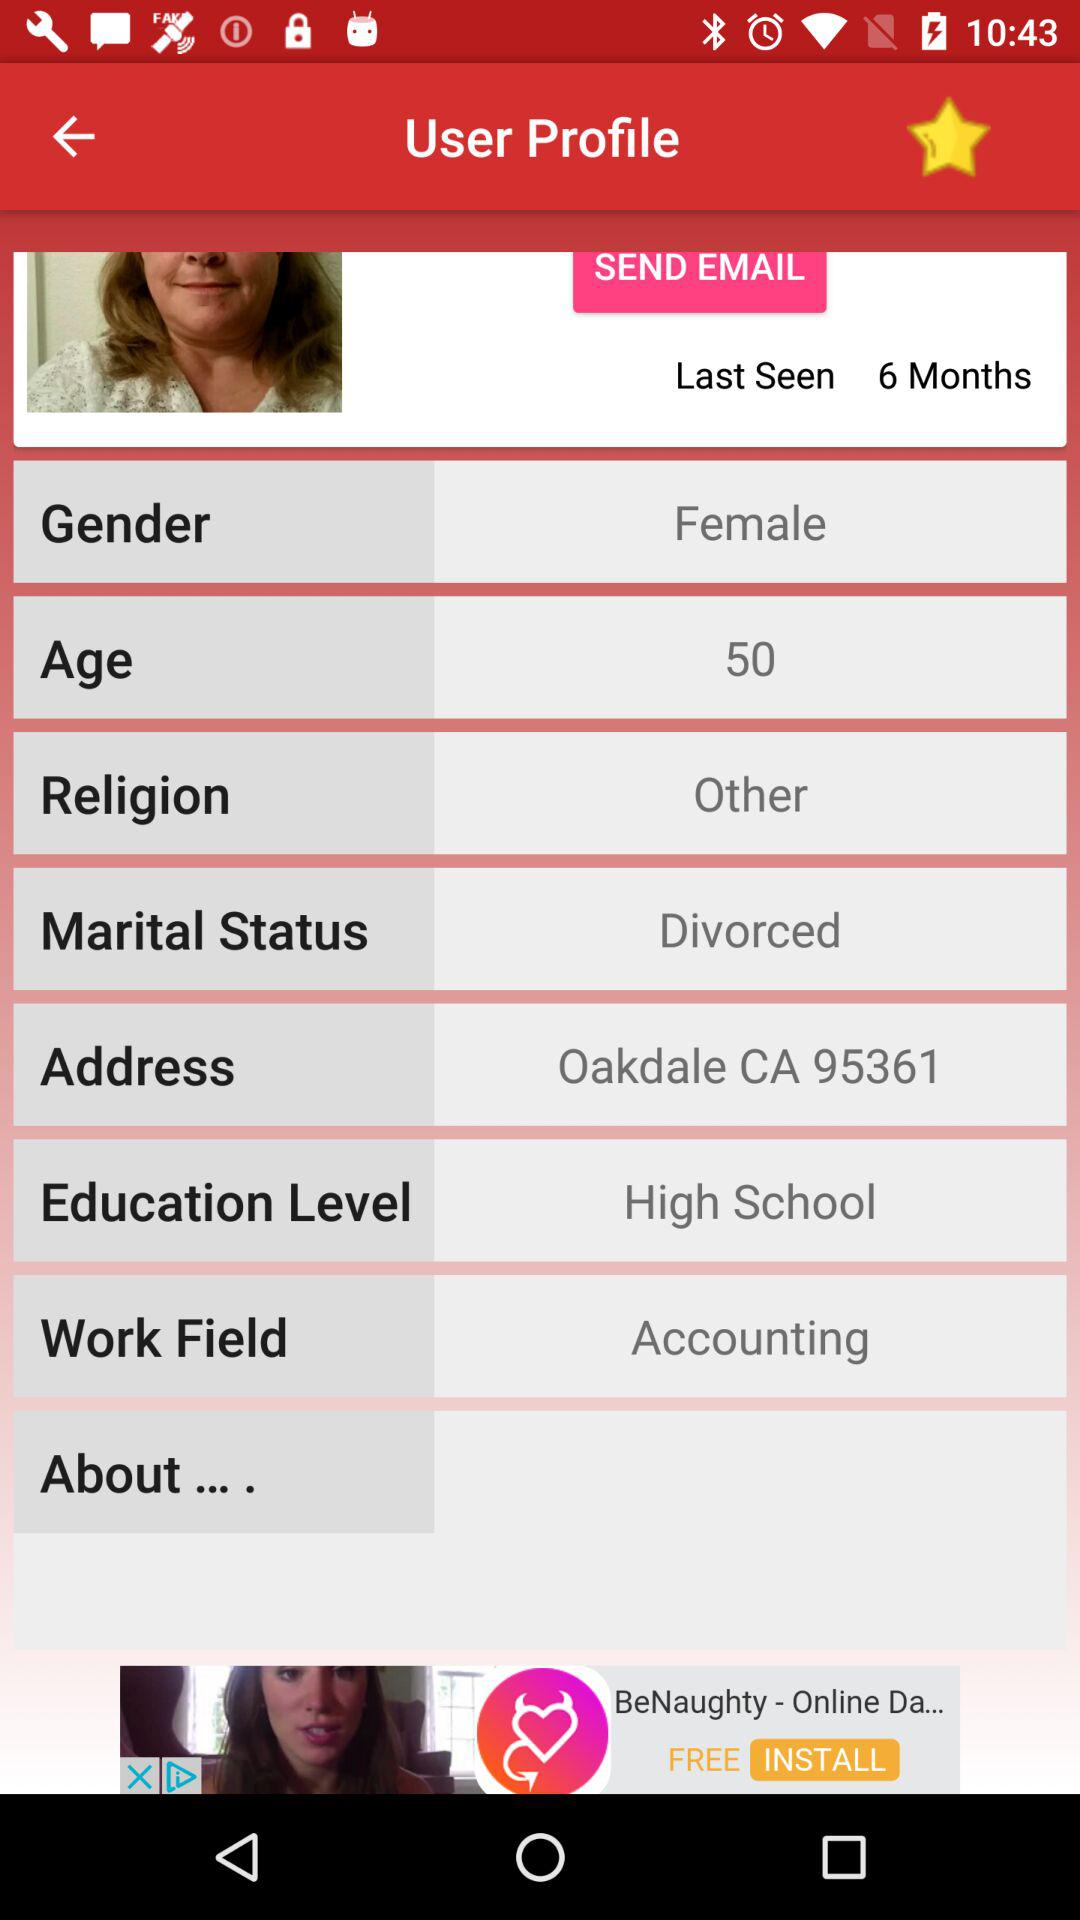What is the marital status of the user? The marital status is divorced. 